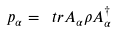<formula> <loc_0><loc_0><loc_500><loc_500>p _ { \alpha } = \ t r A _ { \alpha } \rho A ^ { \dagger } _ { \alpha }</formula> 